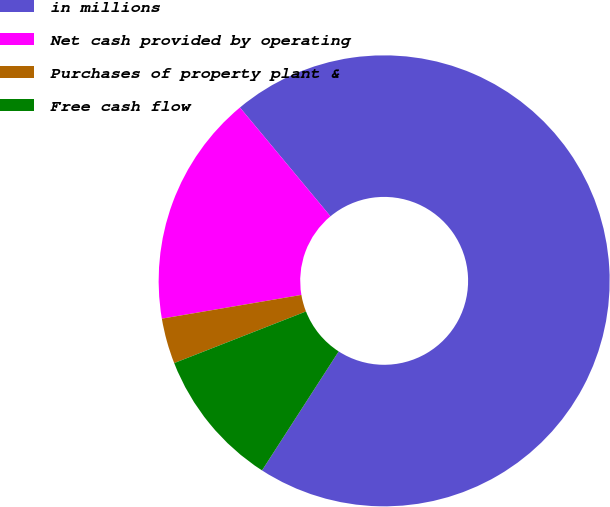Convert chart. <chart><loc_0><loc_0><loc_500><loc_500><pie_chart><fcel>in millions<fcel>Net cash provided by operating<fcel>Purchases of property plant &<fcel>Free cash flow<nl><fcel>70.16%<fcel>16.64%<fcel>3.26%<fcel>9.95%<nl></chart> 